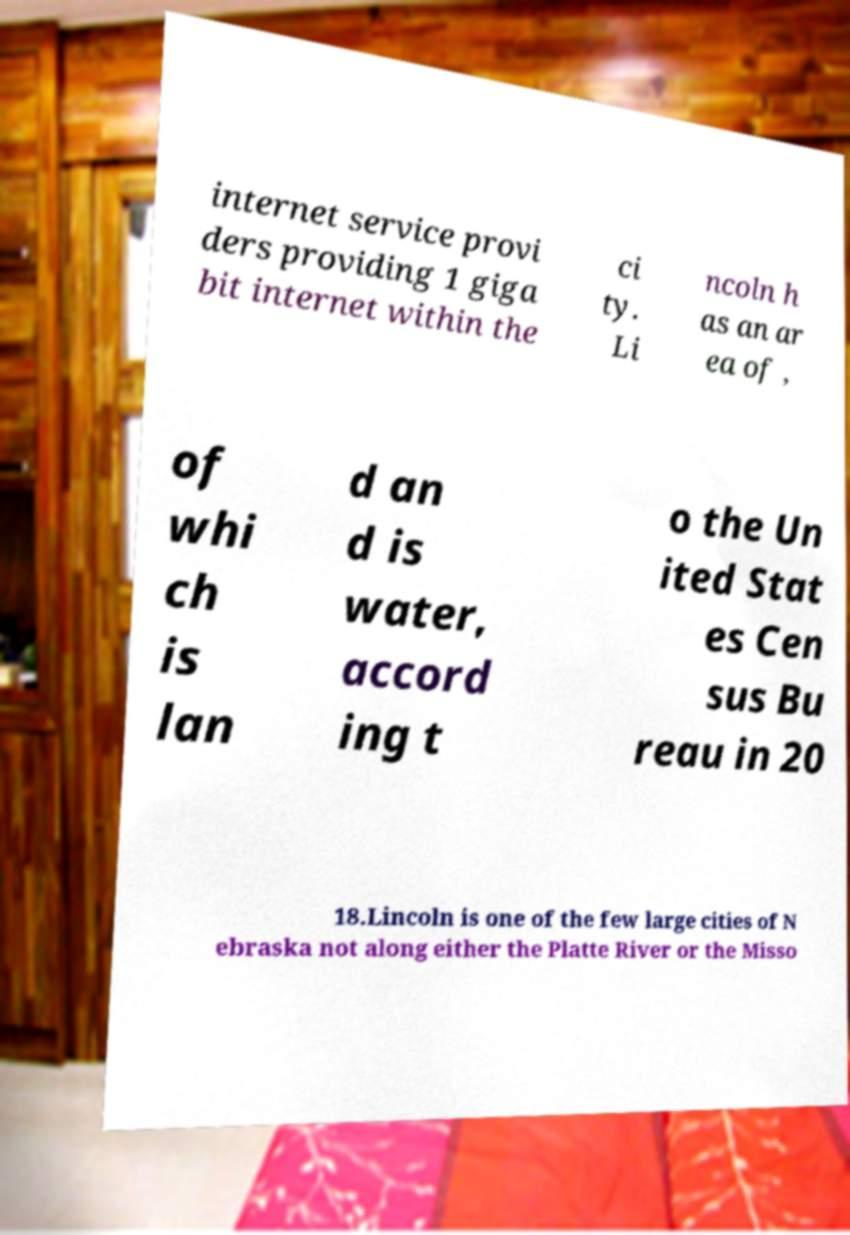I need the written content from this picture converted into text. Can you do that? internet service provi ders providing 1 giga bit internet within the ci ty. Li ncoln h as an ar ea of , of whi ch is lan d an d is water, accord ing t o the Un ited Stat es Cen sus Bu reau in 20 18.Lincoln is one of the few large cities of N ebraska not along either the Platte River or the Misso 